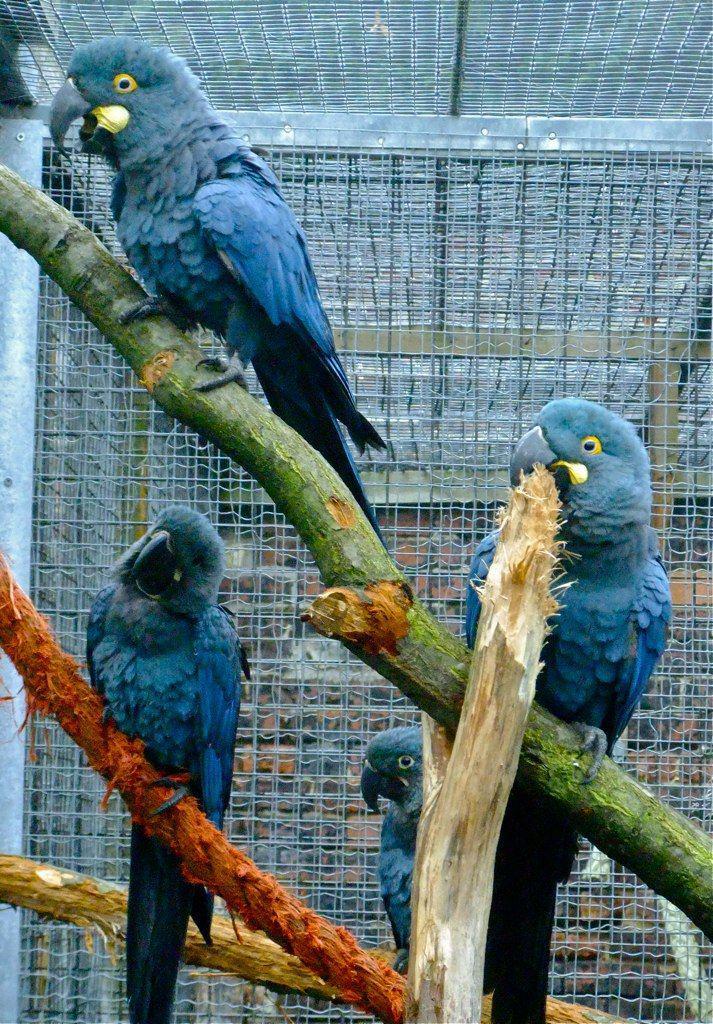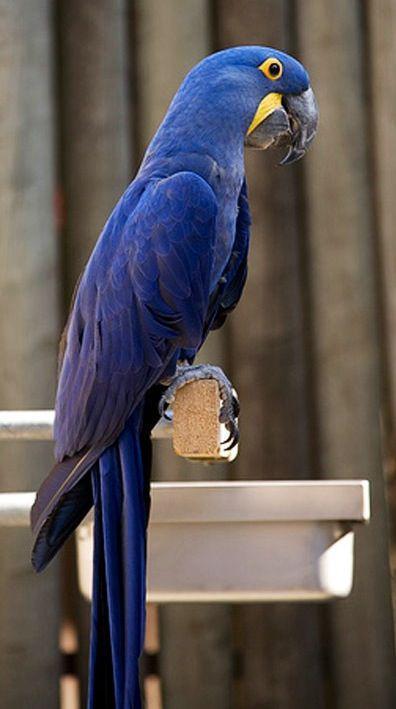The first image is the image on the left, the second image is the image on the right. Examine the images to the left and right. Is the description "In one image, a single blue parrot is sitting on a perch." accurate? Answer yes or no. Yes. The first image is the image on the left, the second image is the image on the right. For the images shown, is this caption "An image shows exactly one parrot, which is blue." true? Answer yes or no. Yes. 